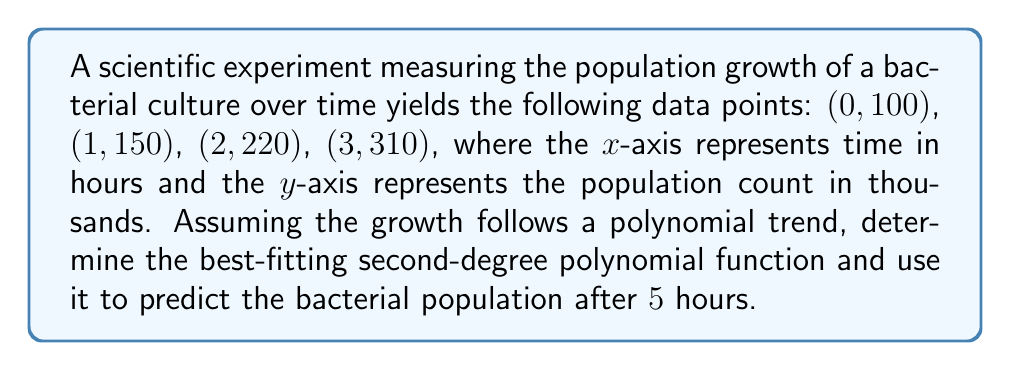What is the answer to this math problem? To solve this problem, we'll follow these steps:

1. Find the second-degree polynomial function that best fits the given data points.
2. Use the function to predict the population at t = 5 hours.

Step 1: Finding the best-fitting polynomial function

We'll use the general form of a second-degree polynomial: $f(t) = at^2 + bt + c$

To find the coefficients a, b, and c, we'll use a system of equations:

$$\begin{cases}
100 = a(0)^2 + b(0) + c \\
150 = a(1)^2 + b(1) + c \\
220 = a(2)^2 + b(2) + c \\
310 = a(3)^2 + b(3) + c
\end{cases}$$

Simplifying:

$$\begin{cases}
100 = c \\
150 = a + b + c \\
220 = 4a + 2b + c \\
310 = 9a + 3b + c
\end{cases}$$

Solving this system of equations (using substitution or matrix methods), we get:

$a = 10$
$b = 40$
$c = 100$

Therefore, the best-fitting polynomial function is:

$f(t) = 10t^2 + 40t + 100$

Step 2: Predicting the population at t = 5 hours

To predict the population after 5 hours, we simply substitute t = 5 into our function:

$f(5) = 10(5)^2 + 40(5) + 100$
$f(5) = 10(25) + 200 + 100$
$f(5) = 250 + 200 + 100$
$f(5) = 550$

The predicted bacterial population after 5 hours is 550 thousand.
Answer: The predicted bacterial population after 5 hours is 550,000. 